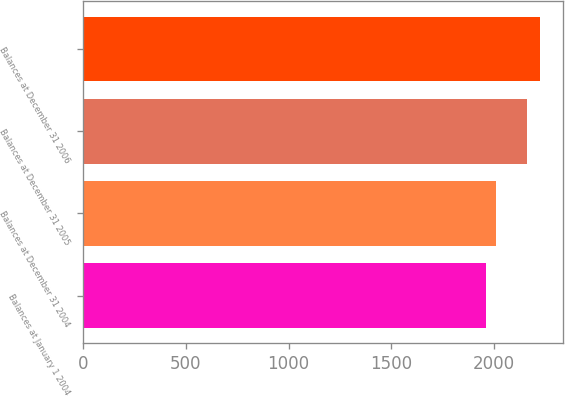Convert chart. <chart><loc_0><loc_0><loc_500><loc_500><bar_chart><fcel>Balances at January 1 2004<fcel>Balances at December 31 2004<fcel>Balances at December 31 2005<fcel>Balances at December 31 2006<nl><fcel>1961<fcel>2012<fcel>2165<fcel>2225<nl></chart> 